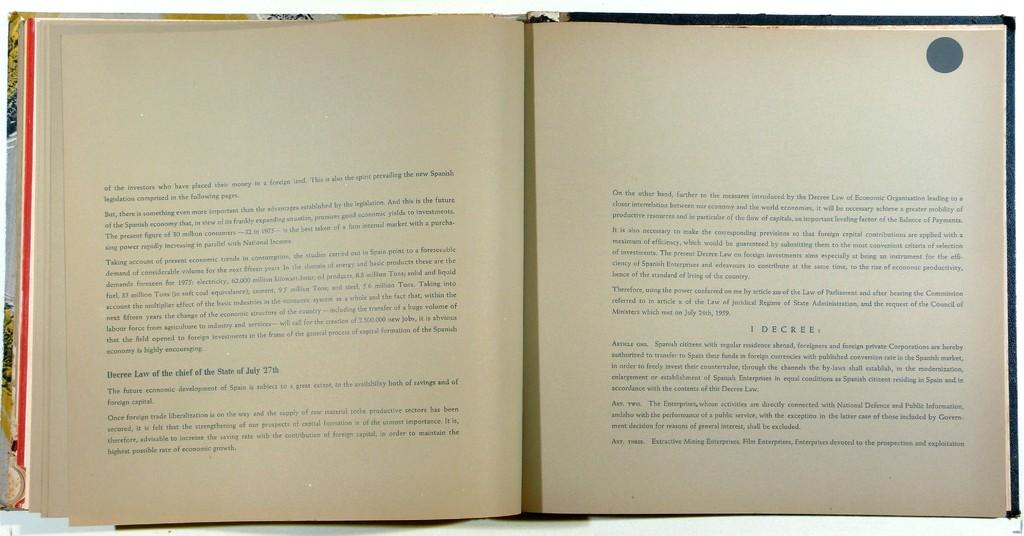<image>
Present a compact description of the photo's key features. A book's pages are open to the decree law of July 27th. 